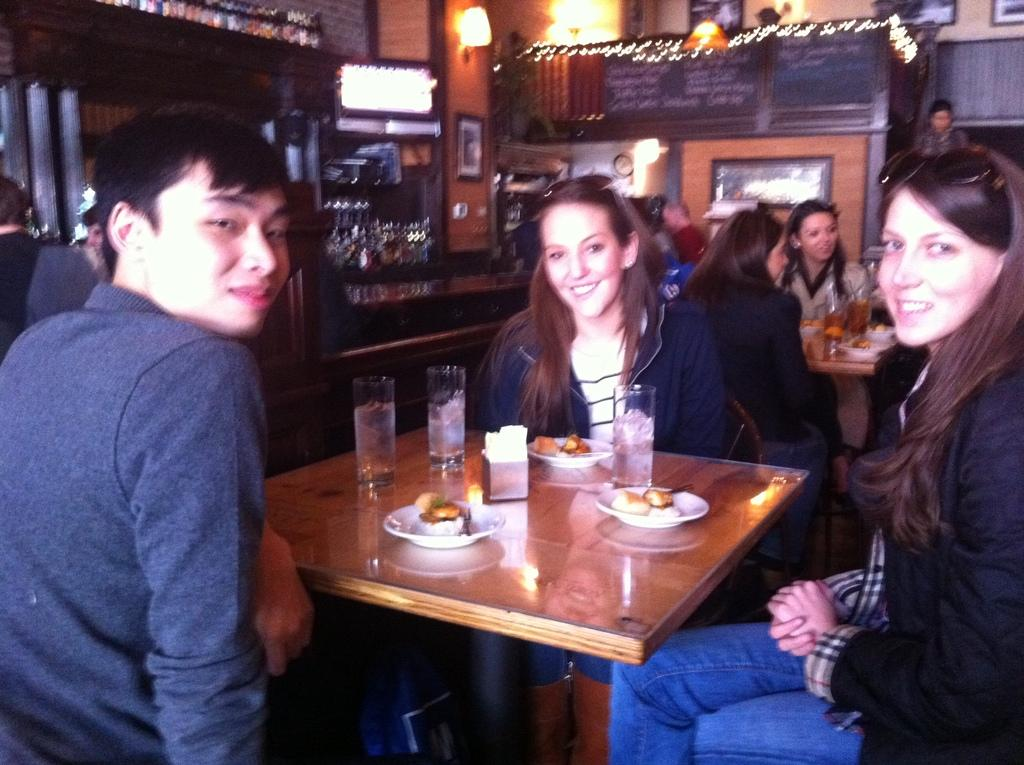What are the people in the image doing? The people in the image are sitting on chairs at a table. What can be found on the table in the image? There is food, tissue paper, and a glass on the table. What can be seen in the background of the image? There is a screen and a wall visible in the background. What is the source of illumination in the image? There are lights visible in the image. Where is the toothbrush located in the image? There is no toothbrush present in the image. What type of game is being played in the image? There is no game or play activity depicted in the image. 